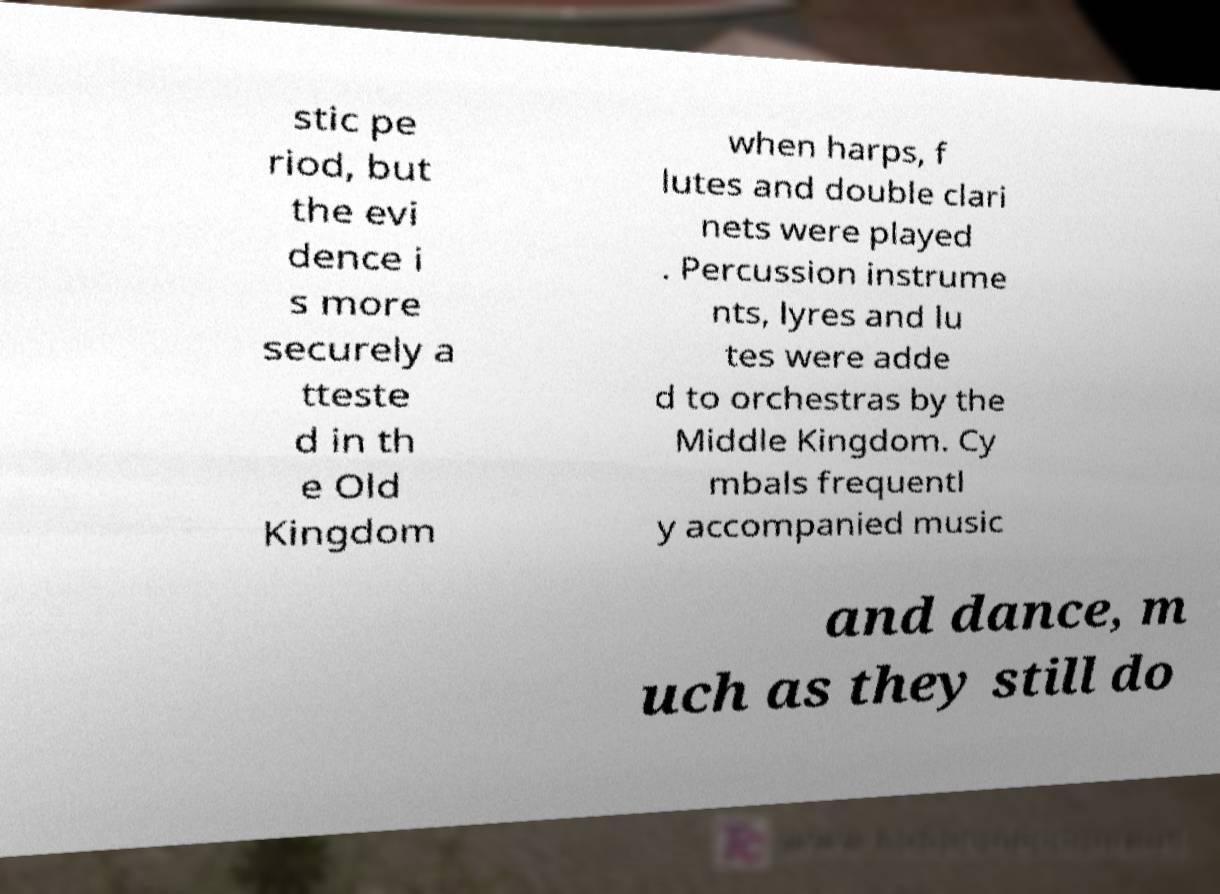Could you assist in decoding the text presented in this image and type it out clearly? stic pe riod, but the evi dence i s more securely a tteste d in th e Old Kingdom when harps, f lutes and double clari nets were played . Percussion instrume nts, lyres and lu tes were adde d to orchestras by the Middle Kingdom. Cy mbals frequentl y accompanied music and dance, m uch as they still do 